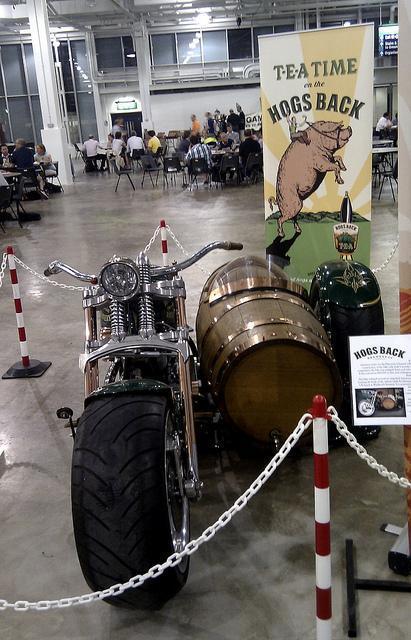How many clocks are in the picture?
Give a very brief answer. 0. 